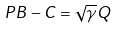Convert formula to latex. <formula><loc_0><loc_0><loc_500><loc_500>P B - C = \sqrt { \gamma } Q</formula> 